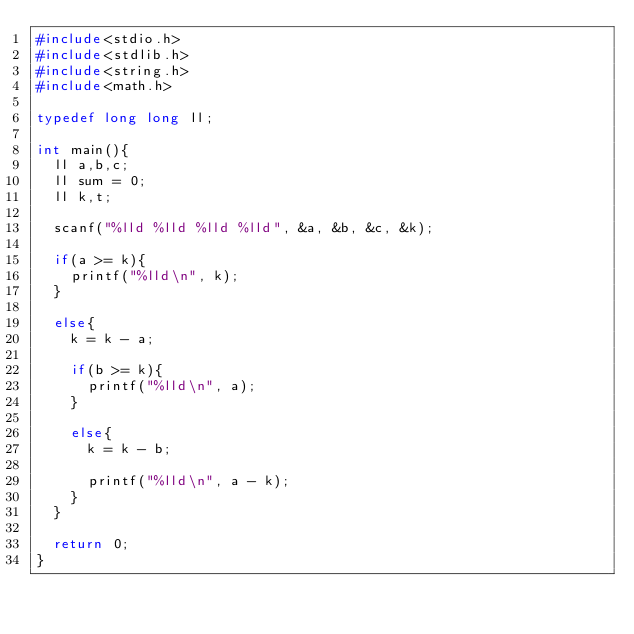Convert code to text. <code><loc_0><loc_0><loc_500><loc_500><_C_>#include<stdio.h>
#include<stdlib.h>
#include<string.h>
#include<math.h>

typedef long long ll;

int main(){
  ll a,b,c;
  ll sum = 0;
  ll k,t;

  scanf("%lld %lld %lld %lld", &a, &b, &c, &k);

  if(a >= k){
    printf("%lld\n", k);
  }

  else{
    k = k - a;

    if(b >= k){
      printf("%lld\n", a);
    }

    else{
      k = k - b;

      printf("%lld\n", a - k);
    }
  }

  return 0;
}</code> 